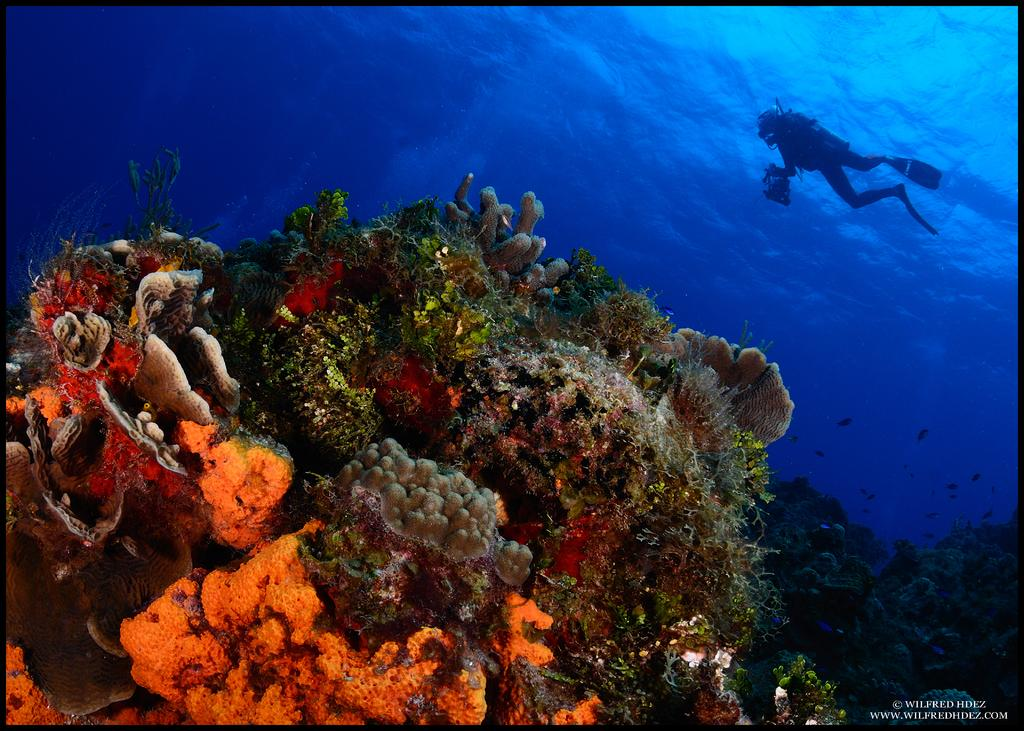What is the main subject of the image? There is a diver in the water. What can be seen behind the diver? There are fish behind the diver. What is in front of the diver? There is a coral reef in front of the diver. Is there any text in the image? Yes, there is some text at the bottom of the image. What type of juice is being squeezed by the machine in the image? There is no juice or machine present in the image; it features a diver in the water with fish and a coral reef. What kind of beast is lurking behind the coral reef in the image? There is no beast present in the image; it only features a diver, fish, and a coral reef. 